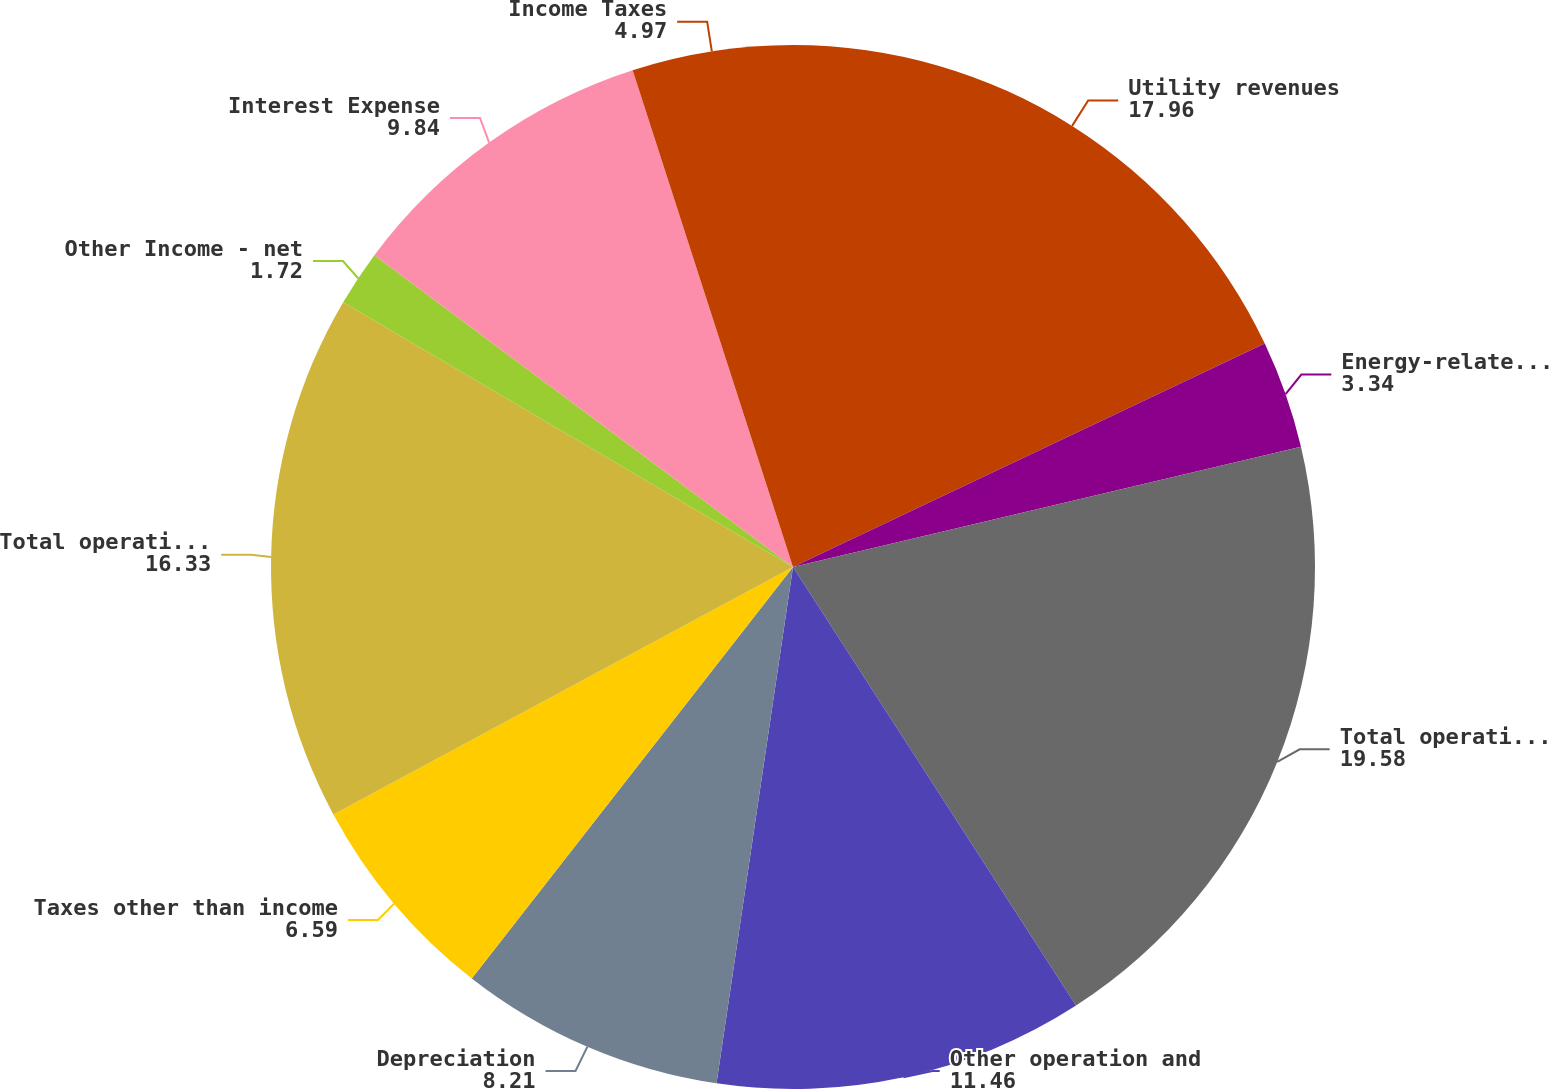Convert chart. <chart><loc_0><loc_0><loc_500><loc_500><pie_chart><fcel>Utility revenues<fcel>Energy-related businesses<fcel>Total operating revenues<fcel>Other operation and<fcel>Depreciation<fcel>Taxes other than income<fcel>Total operating expenses<fcel>Other Income - net<fcel>Interest Expense<fcel>Income Taxes<nl><fcel>17.96%<fcel>3.34%<fcel>19.58%<fcel>11.46%<fcel>8.21%<fcel>6.59%<fcel>16.33%<fcel>1.72%<fcel>9.84%<fcel>4.97%<nl></chart> 